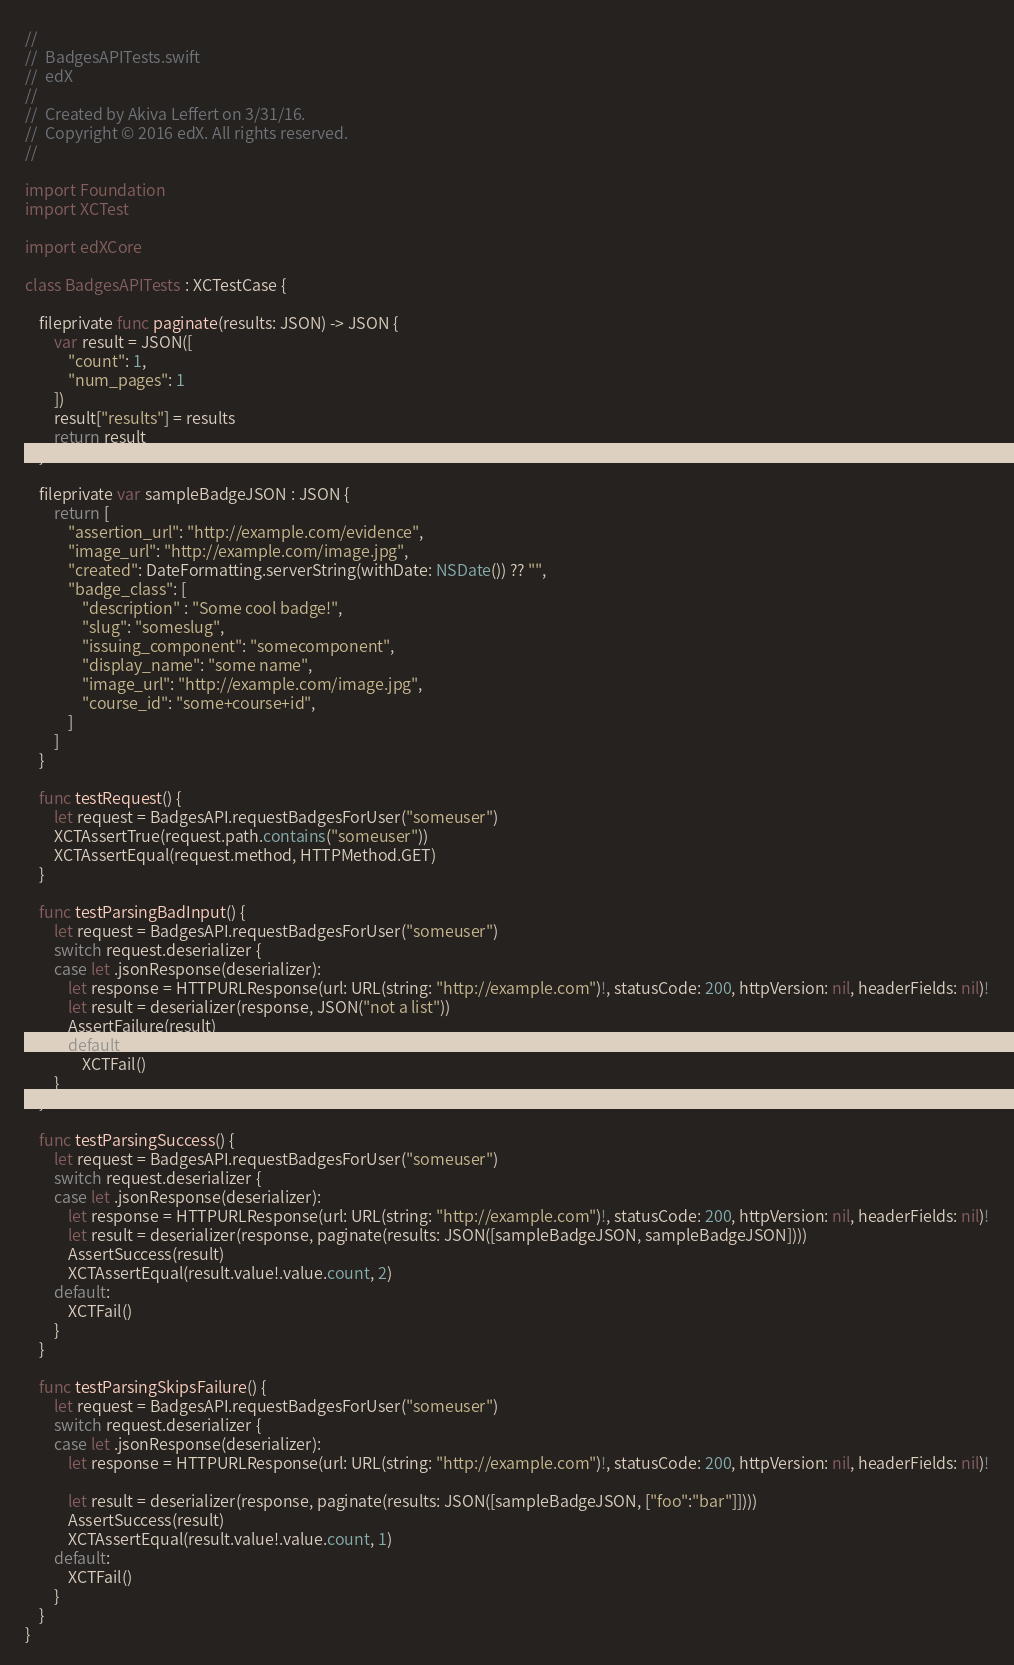Convert code to text. <code><loc_0><loc_0><loc_500><loc_500><_Swift_>//
//  BadgesAPITests.swift
//  edX
//
//  Created by Akiva Leffert on 3/31/16.
//  Copyright © 2016 edX. All rights reserved.
//

import Foundation
import XCTest

import edXCore

class BadgesAPITests : XCTestCase {

    fileprivate func paginate(results: JSON) -> JSON {
        var result = JSON([
            "count": 1,
            "num_pages": 1
        ])
        result["results"] = results
        return result
    }

    fileprivate var sampleBadgeJSON : JSON {
        return [
            "assertion_url": "http://example.com/evidence",
            "image_url": "http://example.com/image.jpg",
            "created": DateFormatting.serverString(withDate: NSDate()) ?? "",
            "badge_class": [
                "description" : "Some cool badge!",
                "slug": "someslug",
                "issuing_component": "somecomponent",
                "display_name": "some name",
                "image_url": "http://example.com/image.jpg",
                "course_id": "some+course+id",
            ]
        ]
    }

    func testRequest() {
        let request = BadgesAPI.requestBadgesForUser("someuser")
        XCTAssertTrue(request.path.contains("someuser"))
        XCTAssertEqual(request.method, HTTPMethod.GET)
    }

    func testParsingBadInput() {
        let request = BadgesAPI.requestBadgesForUser("someuser")
        switch request.deserializer {
        case let .jsonResponse(deserializer):
            let response = HTTPURLResponse(url: URL(string: "http://example.com")!, statusCode: 200, httpVersion: nil, headerFields: nil)!
            let result = deserializer(response, JSON("not a list"))
            AssertFailure(result)
            default:
                XCTFail()
        }
    }

    func testParsingSuccess() {
        let request = BadgesAPI.requestBadgesForUser("someuser")
        switch request.deserializer {
        case let .jsonResponse(deserializer):
            let response = HTTPURLResponse(url: URL(string: "http://example.com")!, statusCode: 200, httpVersion: nil, headerFields: nil)!
            let result = deserializer(response, paginate(results: JSON([sampleBadgeJSON, sampleBadgeJSON])))
            AssertSuccess(result)
            XCTAssertEqual(result.value!.value.count, 2)
        default:
            XCTFail()
        }
    }

    func testParsingSkipsFailure() {
        let request = BadgesAPI.requestBadgesForUser("someuser")
        switch request.deserializer {
        case let .jsonResponse(deserializer):
            let response = HTTPURLResponse(url: URL(string: "http://example.com")!, statusCode: 200, httpVersion: nil, headerFields: nil)!

            let result = deserializer(response, paginate(results: JSON([sampleBadgeJSON, ["foo":"bar"]])))
            AssertSuccess(result)
            XCTAssertEqual(result.value!.value.count, 1)
        default:
            XCTFail()
        }
    }
}
</code> 